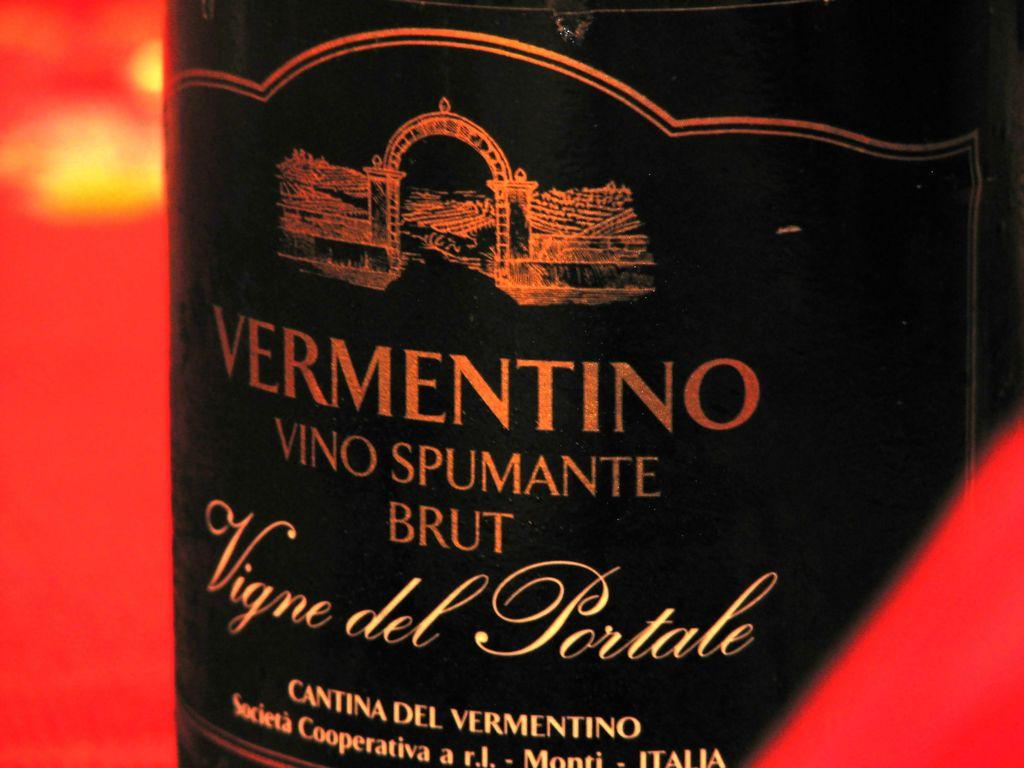<image>
Share a concise interpretation of the image provided. The black Label for Vermentino sparkliing wine with an illustration on the top of the label. 